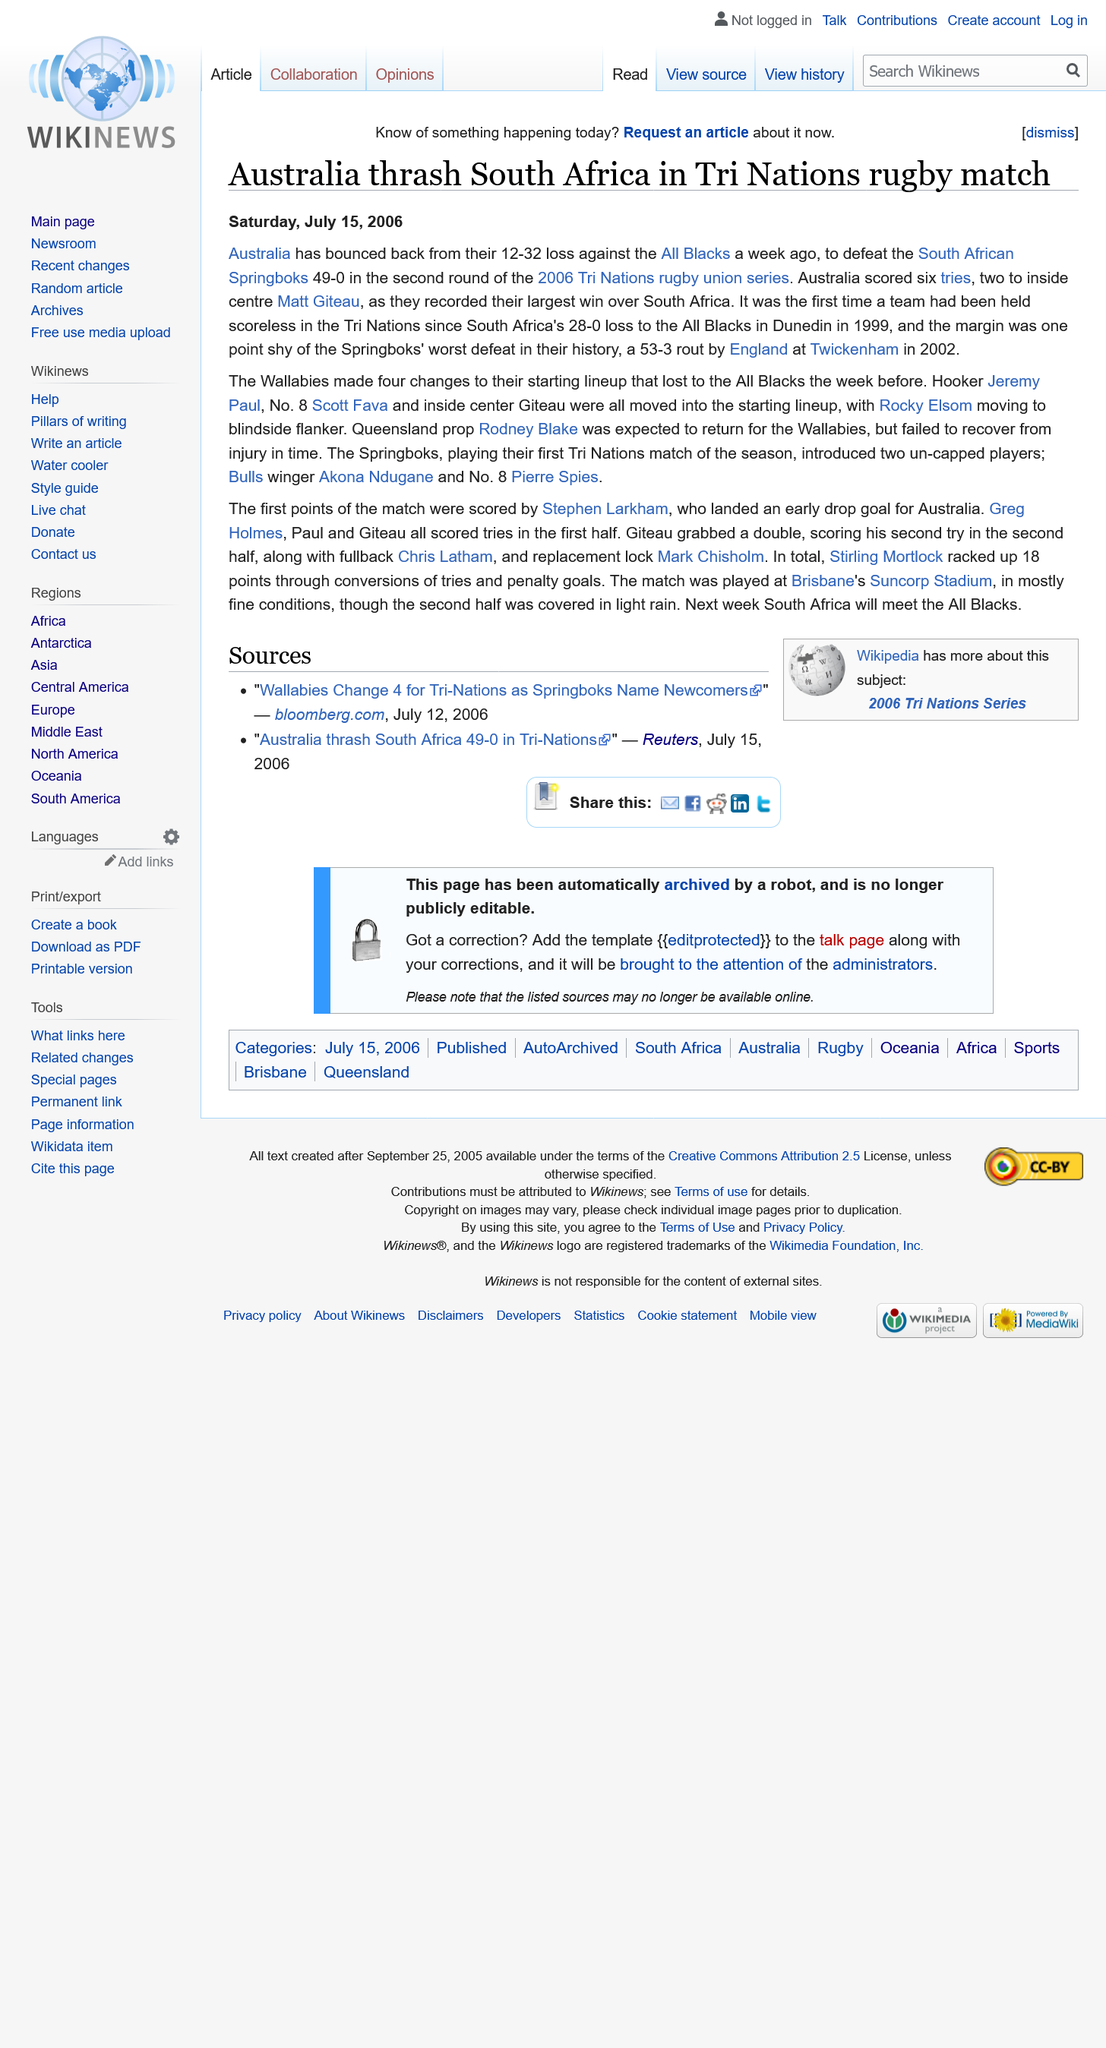Outline some significant characteristics in this image. The last time a team did not score in the Tri Nations was in 1999. Australia scored six tries in total during the match. In the rugby match between Australia and South Africa, the score was 49-0 in favor of Australia, and Australia made four changes to their starting lineup. 